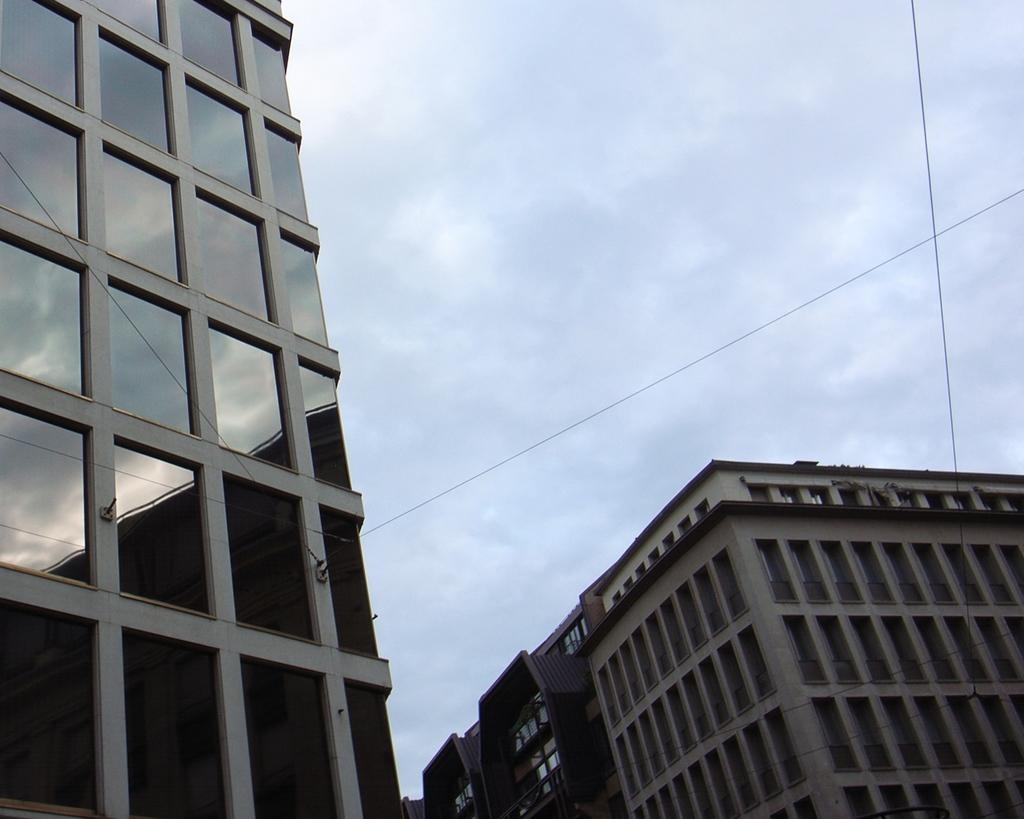What structures are present in the image? There are buildings in the image. What feature can be observed on the buildings? The buildings have windows. What else is visible in the image besides the buildings? There are wires visible in the image. What is visible at the top of the image? The sky is visible in the image, and it looks cloudy. Can you tell me how many pencils are being used to draw the buildings in the image? There is no indication in the image that the buildings are being drawn with pencils, and therefore no such information can be provided. What type of plants can be seen growing on the buildings in the image? There are no plants visible on the buildings in the image. 